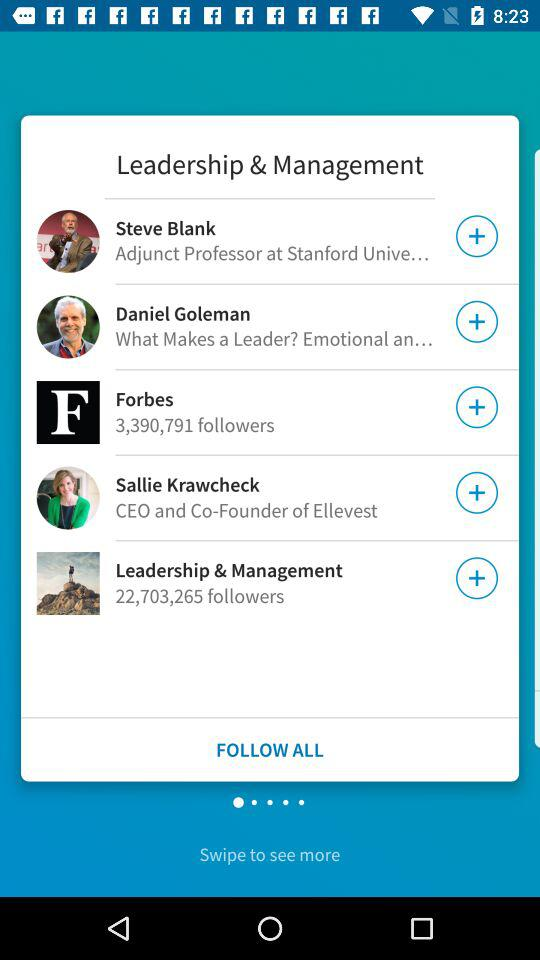How many followers are there for "Leadership & Management"? There are 22,703,265 followers. 